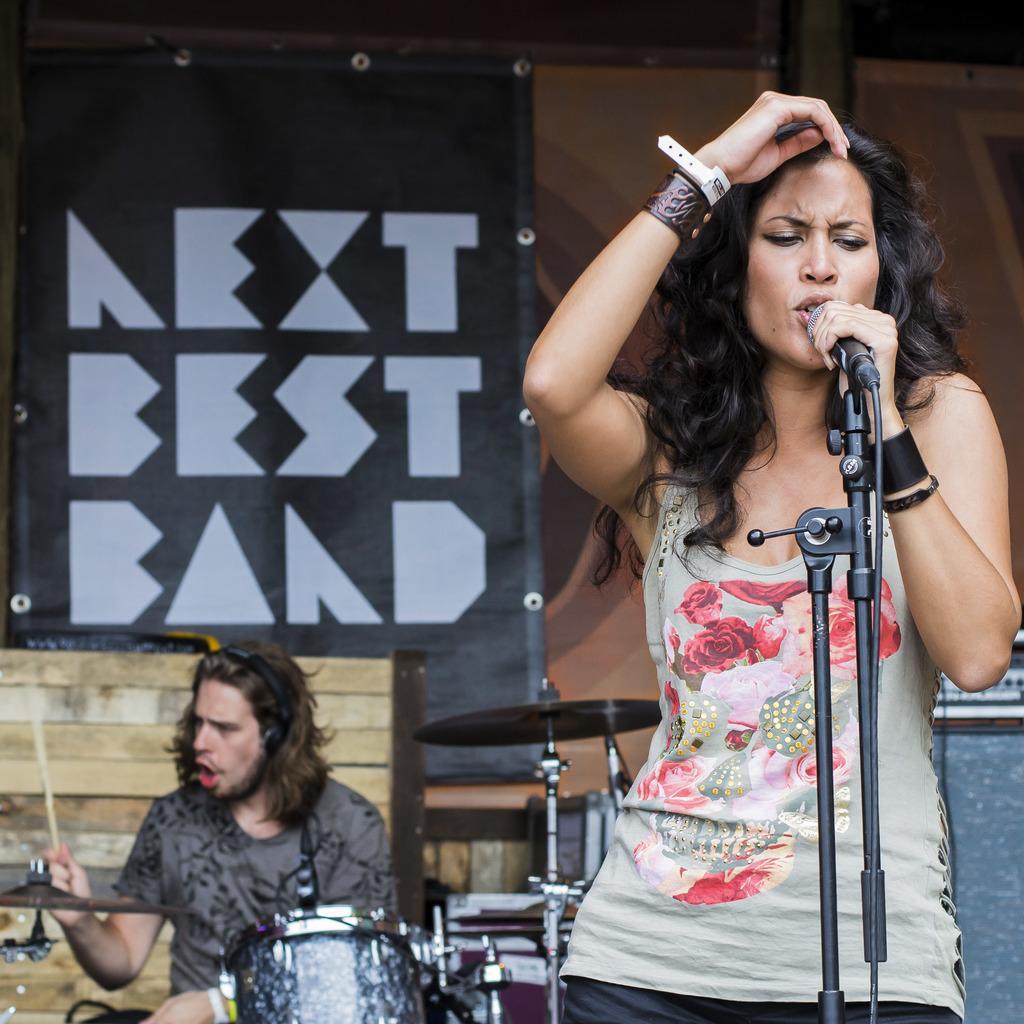Can you describe this image briefly? In this picture we can see woman standing and singing on mic and at back of her we can see man sitting and playing drums and in background we can see wall, board. 